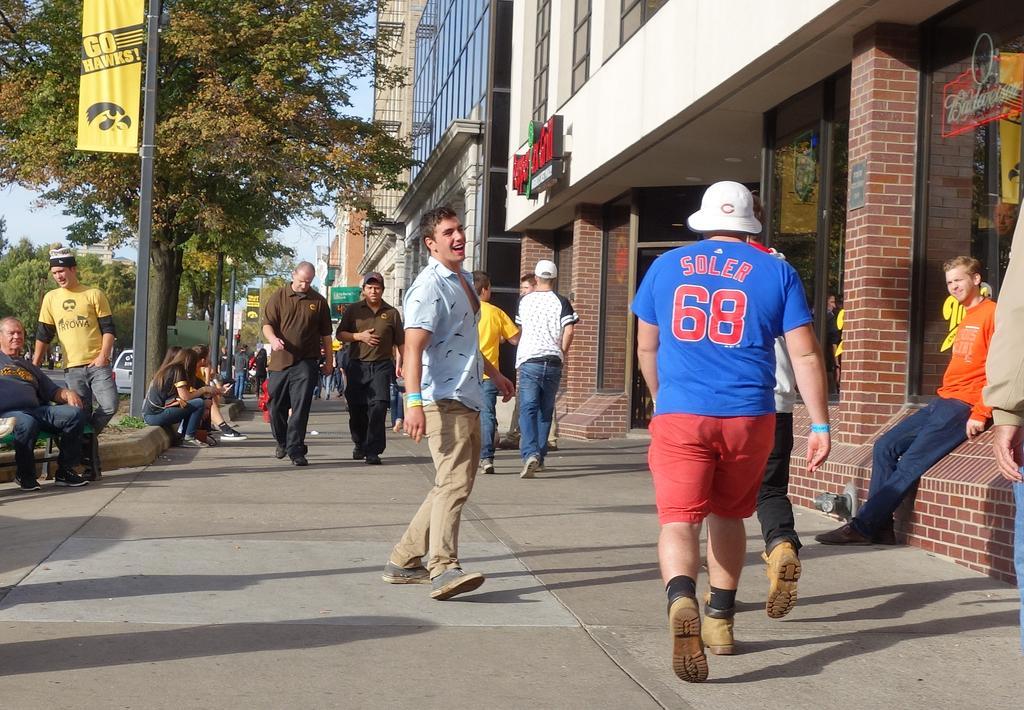In one or two sentences, can you explain what this image depicts? In this image I can see the group of people with different color dresses. I can see few people are sitting and few people are walking. To the side of these people I can see the building. To the left I can see the banner to the pole and many trees. In the background I can see the sky. 